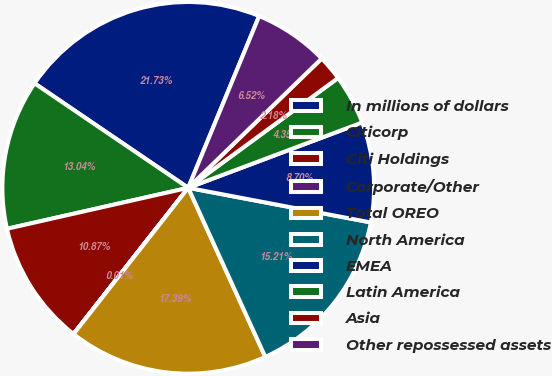Convert chart. <chart><loc_0><loc_0><loc_500><loc_500><pie_chart><fcel>In millions of dollars<fcel>Citicorp<fcel>Citi Holdings<fcel>Corporate/Other<fcel>Total OREO<fcel>North America<fcel>EMEA<fcel>Latin America<fcel>Asia<fcel>Other repossessed assets<nl><fcel>21.73%<fcel>13.04%<fcel>10.87%<fcel>0.01%<fcel>17.39%<fcel>15.21%<fcel>8.7%<fcel>4.35%<fcel>2.18%<fcel>6.52%<nl></chart> 